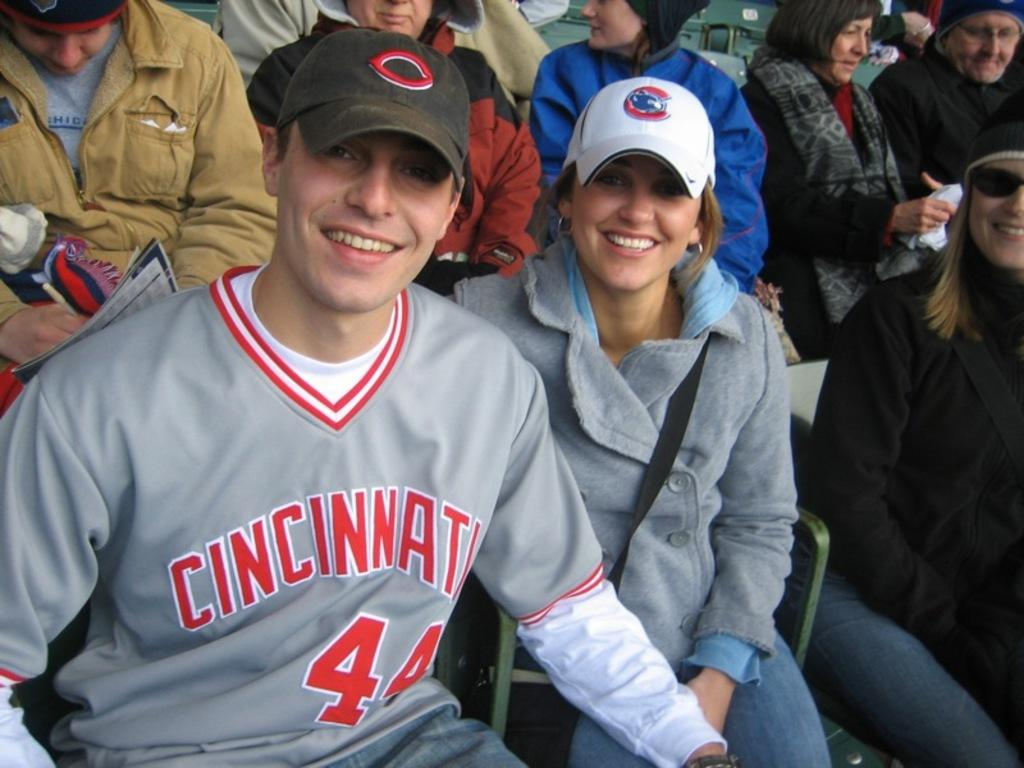How many people are present in the image? There are two people, a man and a woman, present in the image. What is the woman wearing on her head? The woman is wearing a white color cap. What are the man and woman doing in the image? Both the man and woman are sitting on chairs. Can you describe the setting where the man and woman are located? There are other persons sitting in the background of the image, suggesting a group setting or gathering. What type of thought can be seen on the monkey's face in the image? There is no monkey present in the image, so it is not possible to answer that question. 